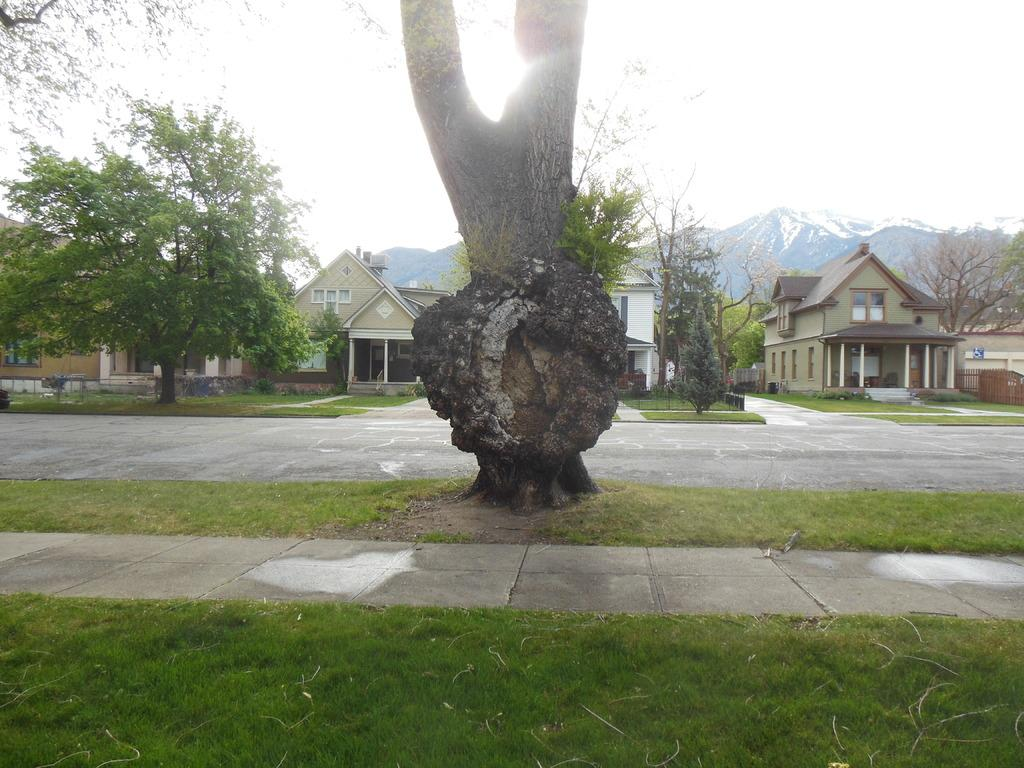What is the main object in the foreground of the image? There is a tree trunk in the image. What structures are visible behind the tree trunk? There are houses behind the tree trunk. What natural feature can be seen beyond the houses? There are mountains visible behind the houses. Are there any other houses in the vicinity? Yes, there are additional houses around the main group of houses. What type of ink is being used to draw the tree trunk in the image? There is no indication that the image is a drawing, and therefore no ink is being used to create the tree trunk. 